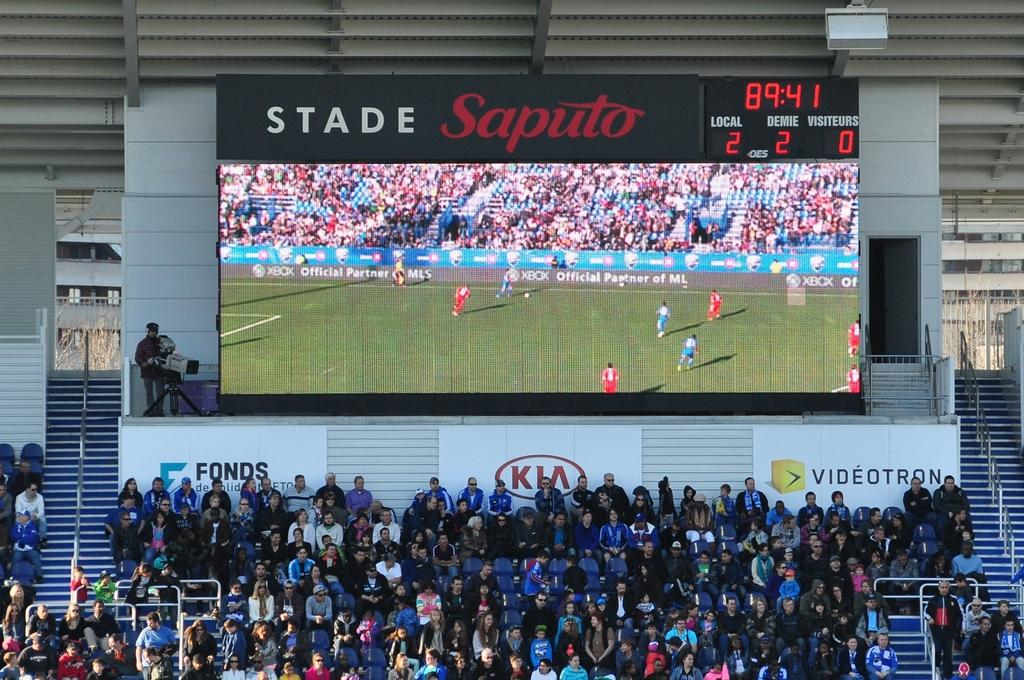<image>
Present a compact description of the photo's key features. A crowd of people sit below a large video display at Stade Saputo. 